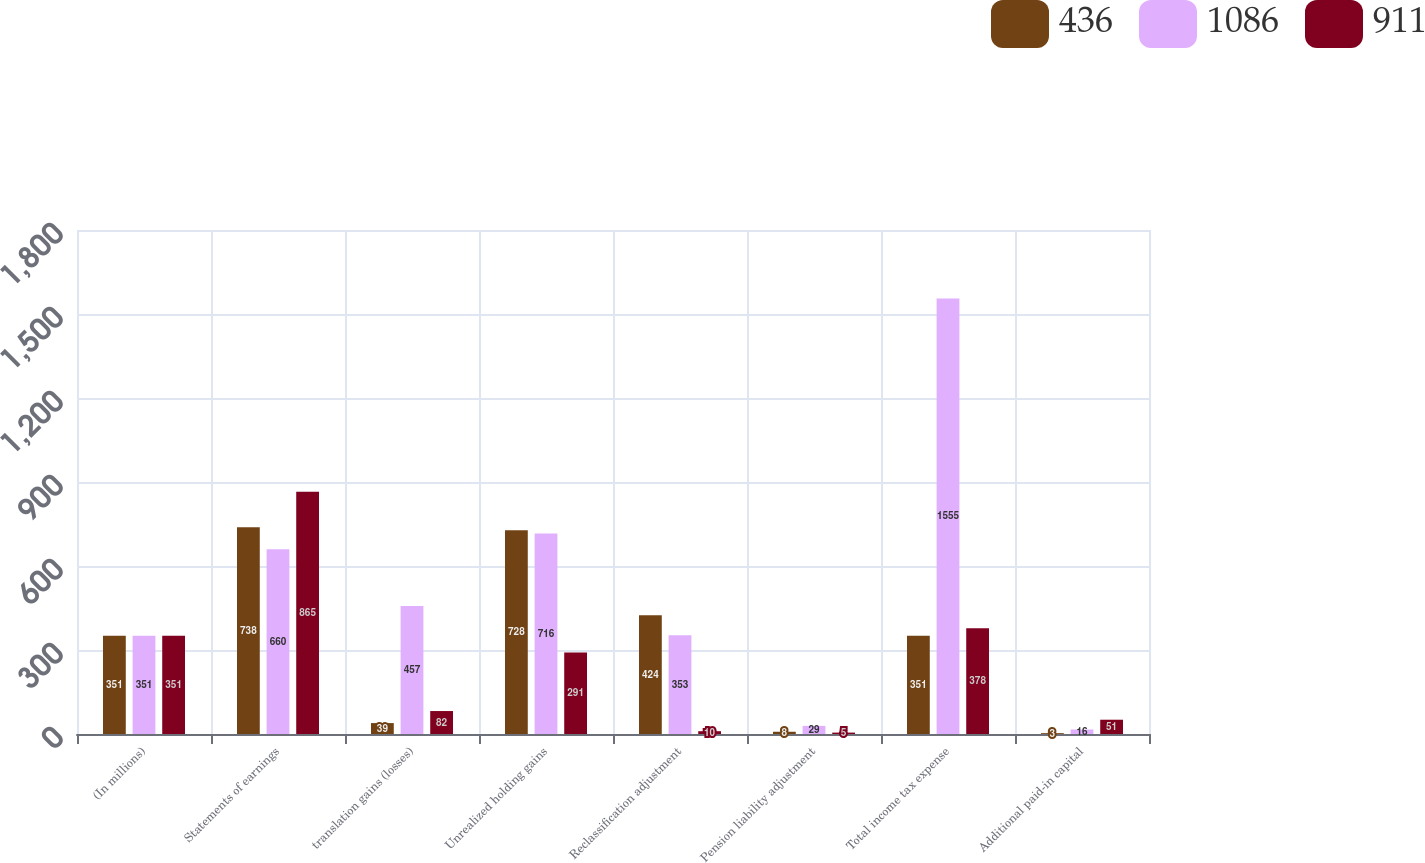Convert chart to OTSL. <chart><loc_0><loc_0><loc_500><loc_500><stacked_bar_chart><ecel><fcel>(In millions)<fcel>Statements of earnings<fcel>translation gains (losses)<fcel>Unrealized holding gains<fcel>Reclassification adjustment<fcel>Pension liability adjustment<fcel>Total income tax expense<fcel>Additional paid-in capital<nl><fcel>436<fcel>351<fcel>738<fcel>39<fcel>728<fcel>424<fcel>8<fcel>351<fcel>3<nl><fcel>1086<fcel>351<fcel>660<fcel>457<fcel>716<fcel>353<fcel>29<fcel>1555<fcel>16<nl><fcel>911<fcel>351<fcel>865<fcel>82<fcel>291<fcel>10<fcel>5<fcel>378<fcel>51<nl></chart> 